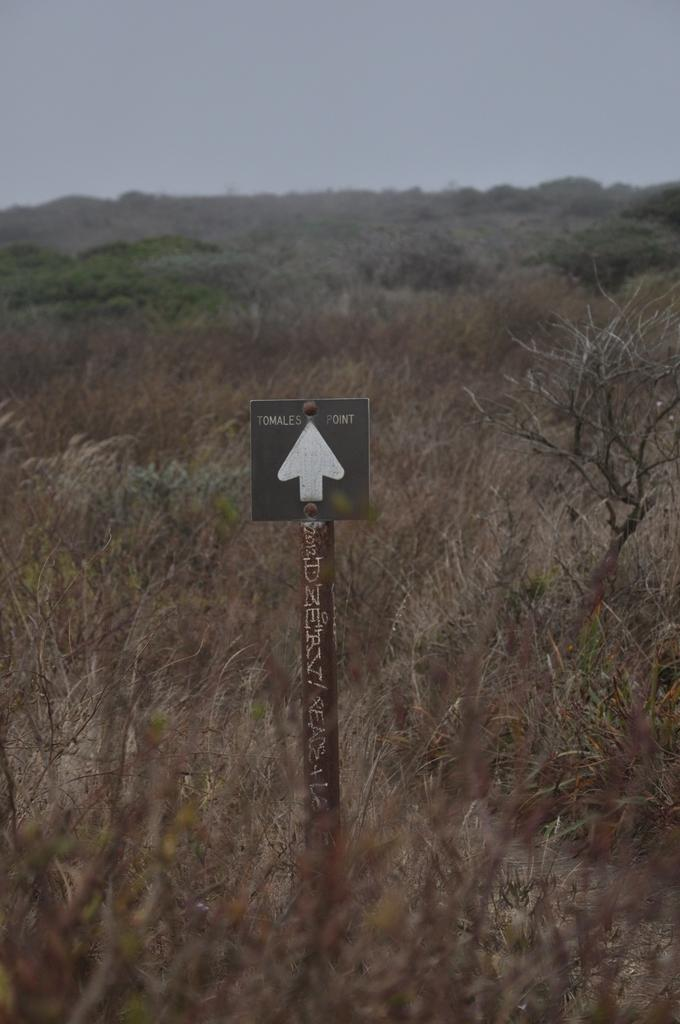What is the main object in the image? There is a pole with a signboard in the image. What can be seen in the background of the image? There are trees and the sky visible in the background of the image. What type of chin can be seen on the signboard in the image? There is no chin present on the signboard in the image. Is there a club visible in the image? There is no club present in the image. 